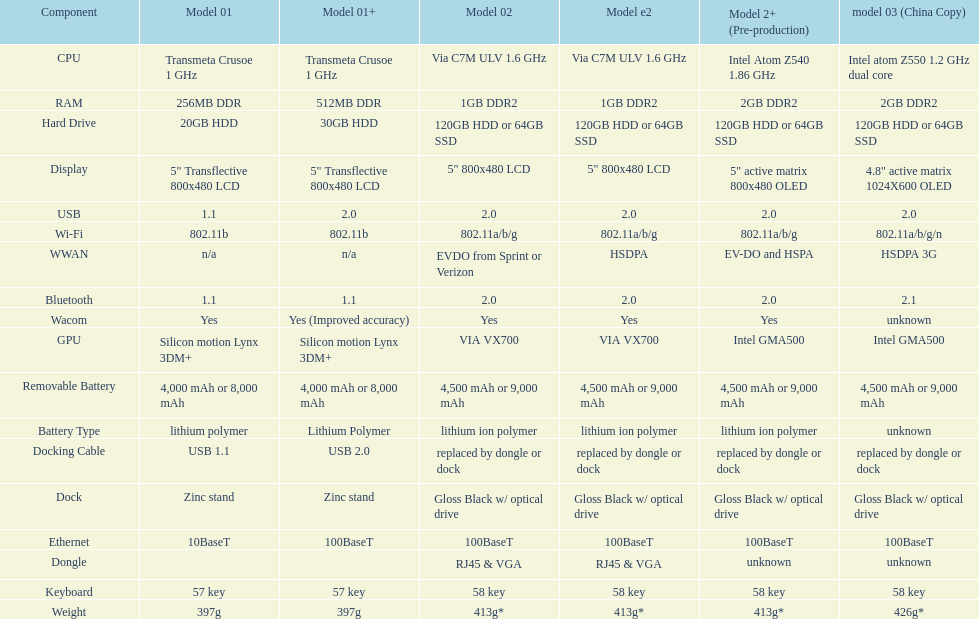What is the cpu type used in the model 2 and model 2e? Via C7M ULV 1.6 GHz. 